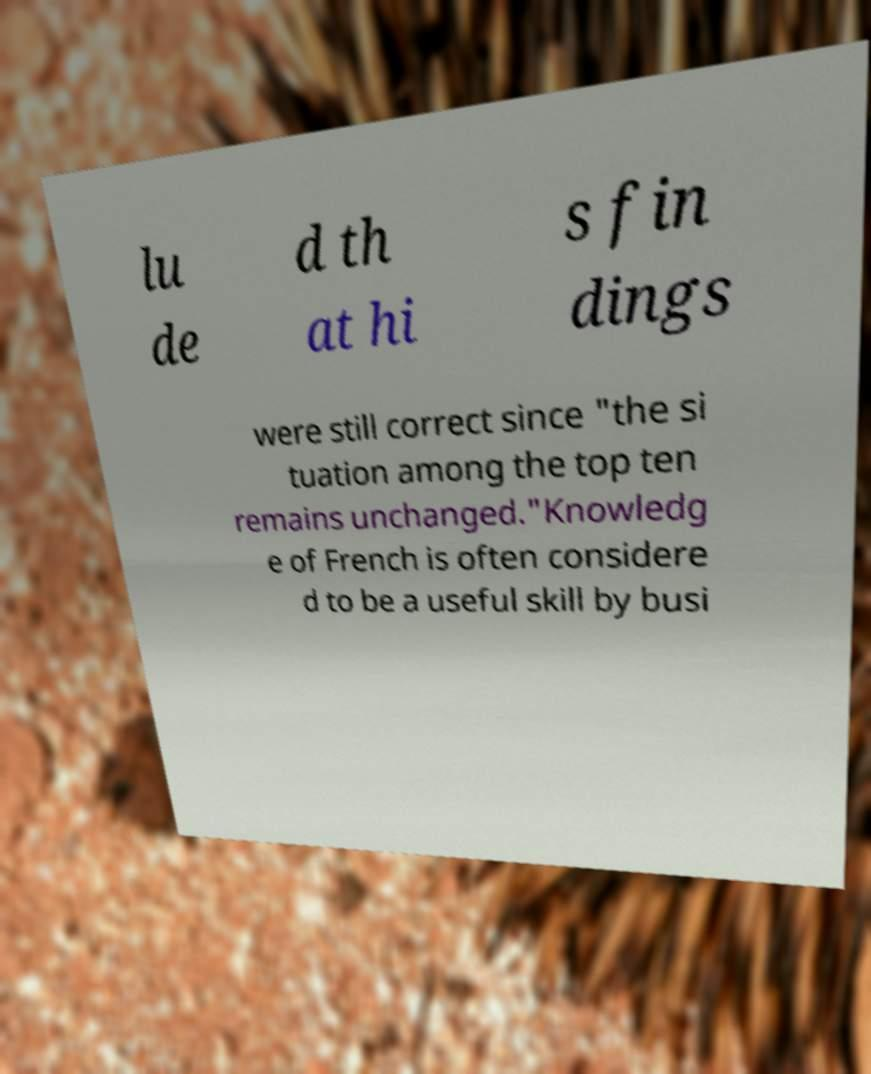There's text embedded in this image that I need extracted. Can you transcribe it verbatim? lu de d th at hi s fin dings were still correct since "the si tuation among the top ten remains unchanged."Knowledg e of French is often considere d to be a useful skill by busi 